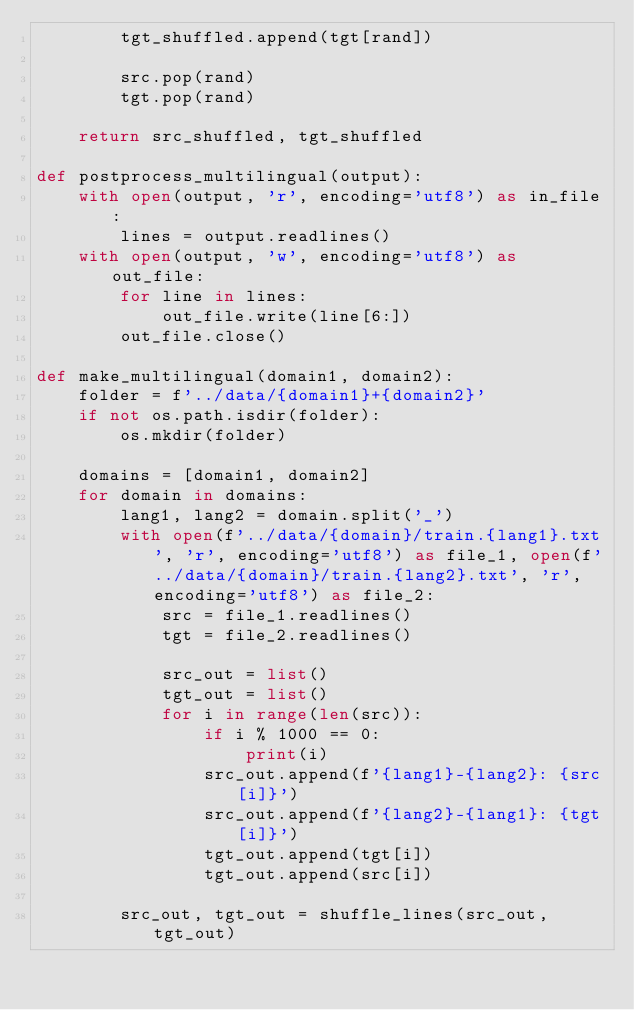<code> <loc_0><loc_0><loc_500><loc_500><_Python_>        tgt_shuffled.append(tgt[rand])

        src.pop(rand)
        tgt.pop(rand)

    return src_shuffled, tgt_shuffled

def postprocess_multilingual(output):
    with open(output, 'r', encoding='utf8') as in_file:
        lines = output.readlines()
    with open(output, 'w', encoding='utf8') as out_file:
        for line in lines:
            out_file.write(line[6:])
        out_file.close()
        
def make_multilingual(domain1, domain2):
    folder = f'../data/{domain1}+{domain2}'
    if not os.path.isdir(folder):
        os.mkdir(folder)

    domains = [domain1, domain2]
    for domain in domains:
        lang1, lang2 = domain.split('_')
        with open(f'../data/{domain}/train.{lang1}.txt', 'r', encoding='utf8') as file_1, open(f'../data/{domain}/train.{lang2}.txt', 'r', encoding='utf8') as file_2:
            src = file_1.readlines()
            tgt = file_2.readlines()

            src_out = list()
            tgt_out = list()
            for i in range(len(src)):
                if i % 1000 == 0:
                    print(i)
                src_out.append(f'{lang1}-{lang2}: {src[i]}')
                src_out.append(f'{lang2}-{lang1}: {tgt[i]}')
                tgt_out.append(tgt[i])
                tgt_out.append(src[i])

        src_out, tgt_out = shuffle_lines(src_out, tgt_out)
</code> 